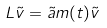Convert formula to latex. <formula><loc_0><loc_0><loc_500><loc_500>L \tilde { v } = \tilde { a } m ( t ) \tilde { v }</formula> 